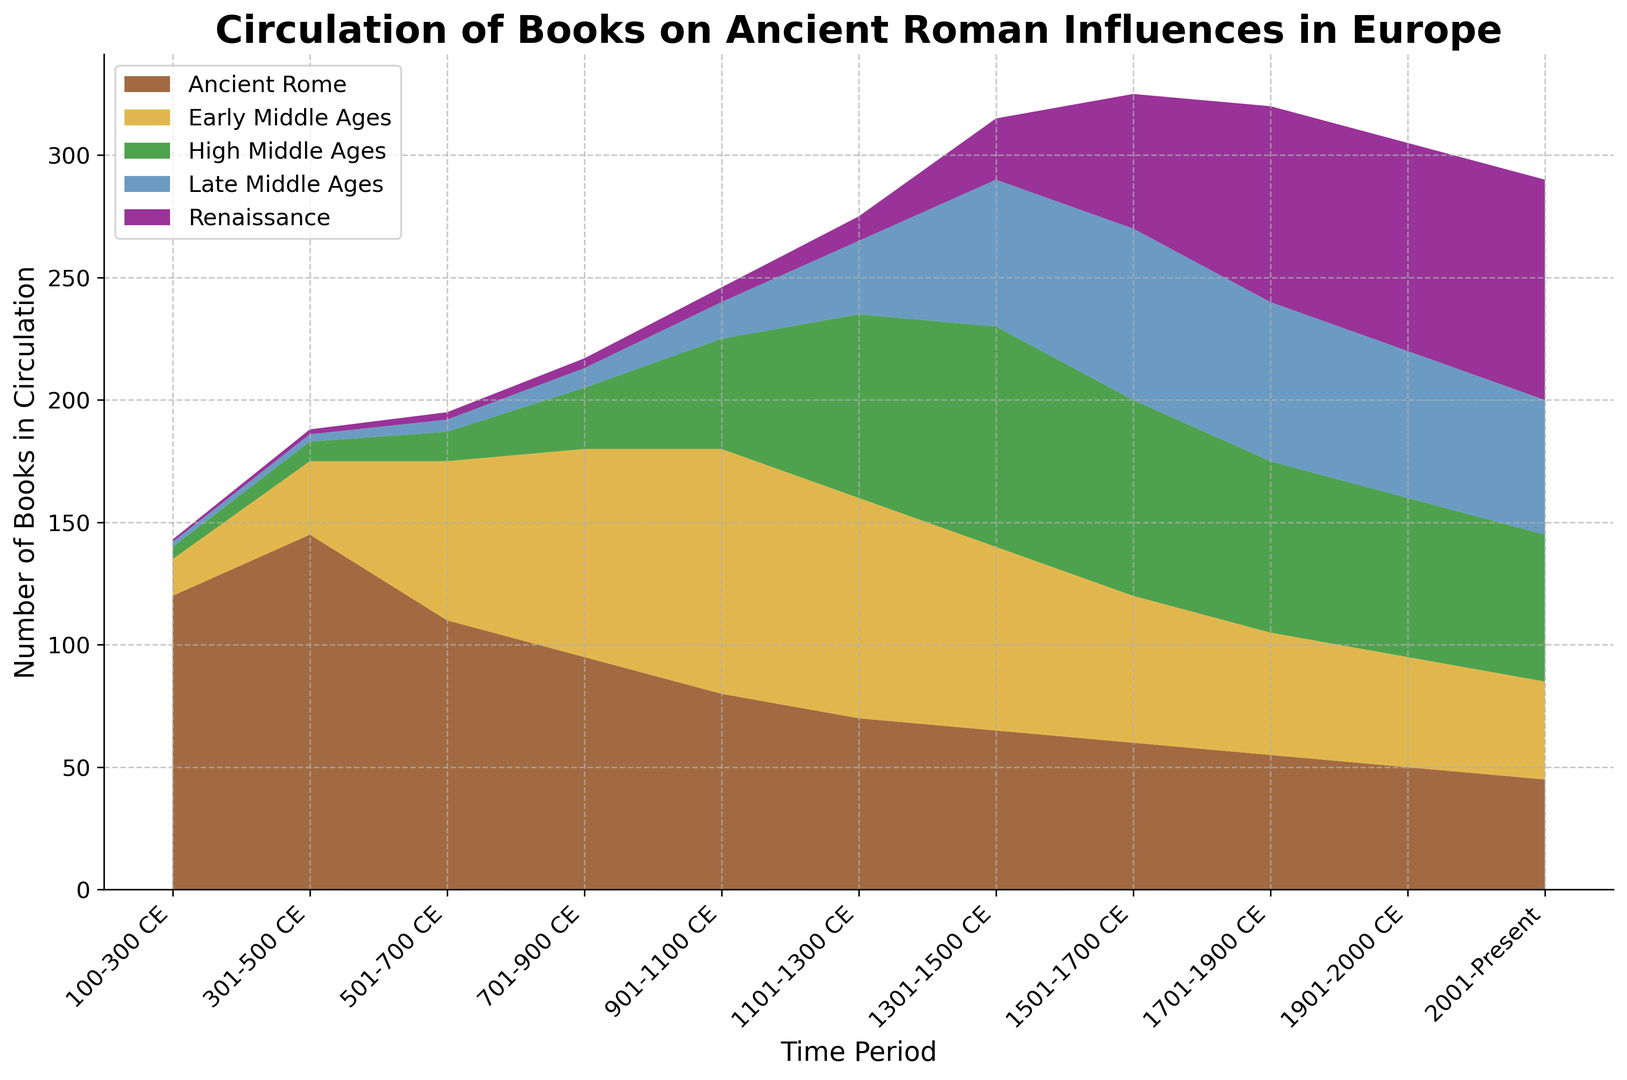What time period saw the highest number of books on Ancient Rome in circulation? To identify the period with the highest number of books on Ancient Rome, look at the heights of the stack for ‘Ancient Rome’ across different periods and find the tallest one. The 301-500 CE period has the tallest stack for Ancient Rome.
Answer: 301-500 CE During which period did books on the Renaissance surpass the circulation of books on the Early Middle Ages? Compare the sizes of the sections representing the Renaissance and the Early Middle Ages over time. The stack size for Renaissance becomes larger than that for the Early Middle Ages in the 1701-1900 CE period.
Answer: 1701-1900 CE Which period marked the peak circulation of books on the High Middle Ages? Look for the period during which the section for the High Middle Ages is the highest. The 1301-1500 CE period has the highest level for the High Middle Ages books.
Answer: 1301-1500 CE In which period was the total circulation for books on Ancient Rome and the Early Middle Ages equal to the circulation of books on the High Middle Ages? Sum the values for 'Ancient Rome' and 'Early Middle Ages' for each period and compare with 'High Middle Ages'. For 301-500 CE: 145 + 30 = 175 and 501-700 CE: 110 + 65 = 175 which both match High Middle Ages: 25 and 45 respectively, so it is the Early Middle Ages considered one period it is 301-500 CE.
Answer: 301-500 CE By how much did the circulation of books on the Late Middle Ages increase from the period 1101-1300 CE to 1501-1700 CE? Subtract the number of books in the 1101-1300 CE period from that in the 1501-1700 CE period. The numbers are 70 (1501-1700 CE) and 30 (1101-1300 CE), so the increase is 70 - 30 = 40.
Answer: 40 What is the overall trend in circulation for books on the Renaissance over time? Look at the section for the Renaissance across all time periods to see if it generally increases, decreases, or stays the same over time. The section for the Renaissance generally increases over time.
Answer: Increasing Was there ever a period where the circulation of books on the Renaissance was less than the circulation of books on all the other periods combined? Sum the values for 'Ancient Rome', 'Early Middle Ages’, 'High Middle Ages', and 'Late Middle Ages' for each period and compare it to the value for 'Renaissance’. For 100-300 CE, the numbers are: 120 + 15 + 5 + 2 = 142, which is greater than 1. This pattern follows until 1100 CE.
Answer: Yes, from 100-300 CE to 901-1100 CE How does the overall circulation of books on the High Middle Ages compare between the first and last periods shown? Compare the section height for the High Middle Ages in the first time period (100-300 CE) with the last (2001-Present). The circulation grows from 5 to 60.
Answer: Increases Which period has the smallest circulation for books on the Late Middle Ages? Identify the time period where the stack height for the Late Middle Ages is the smallest. The first period, 100-300 CE, has the smallest stack for the Late Middle Ages with a value of 2.
Answer: 100-300 CE 